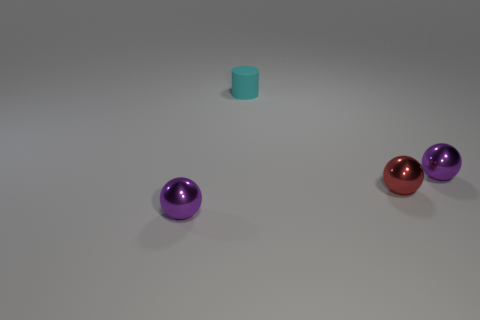Subtract all red shiny balls. How many balls are left? 2 Add 3 shiny cylinders. How many objects exist? 7 Subtract all spheres. How many objects are left? 1 Subtract all purple balls. How many balls are left? 1 Subtract all yellow cylinders. How many red spheres are left? 1 Subtract all red spheres. Subtract all purple spheres. How many objects are left? 1 Add 3 red metal balls. How many red metal balls are left? 4 Add 2 purple objects. How many purple objects exist? 4 Subtract 2 purple spheres. How many objects are left? 2 Subtract 2 balls. How many balls are left? 1 